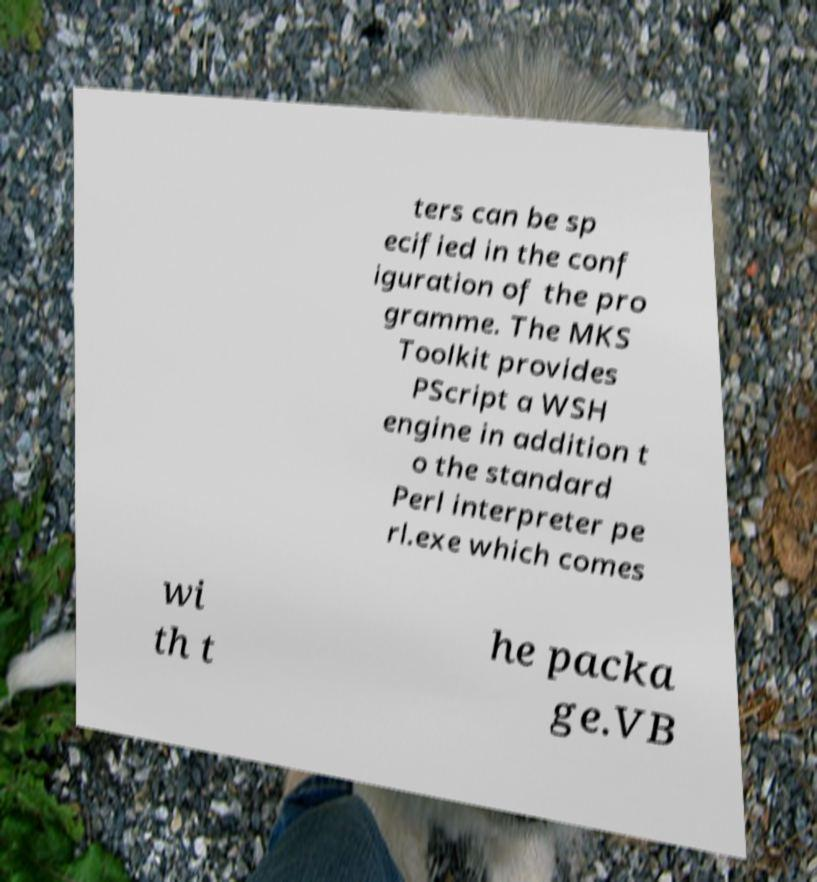Could you extract and type out the text from this image? ters can be sp ecified in the conf iguration of the pro gramme. The MKS Toolkit provides PScript a WSH engine in addition t o the standard Perl interpreter pe rl.exe which comes wi th t he packa ge.VB 